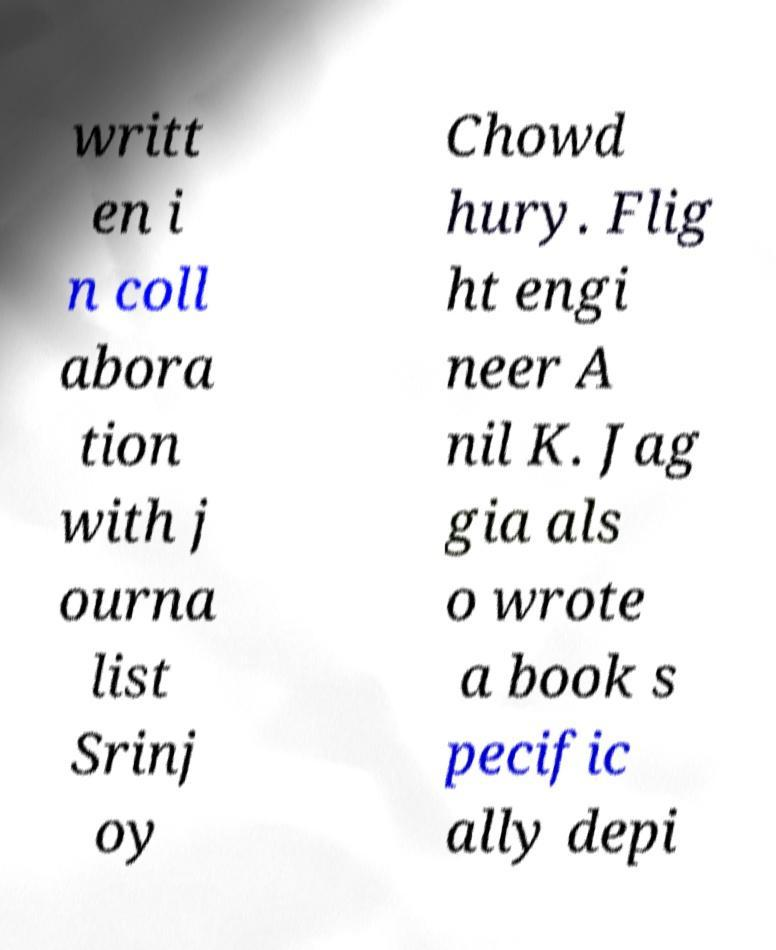Please read and relay the text visible in this image. What does it say? writt en i n coll abora tion with j ourna list Srinj oy Chowd hury. Flig ht engi neer A nil K. Jag gia als o wrote a book s pecific ally depi 